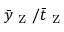<formula> <loc_0><loc_0><loc_500><loc_500>\bar { y } _ { Z } / \bar { t } _ { Z }</formula> 